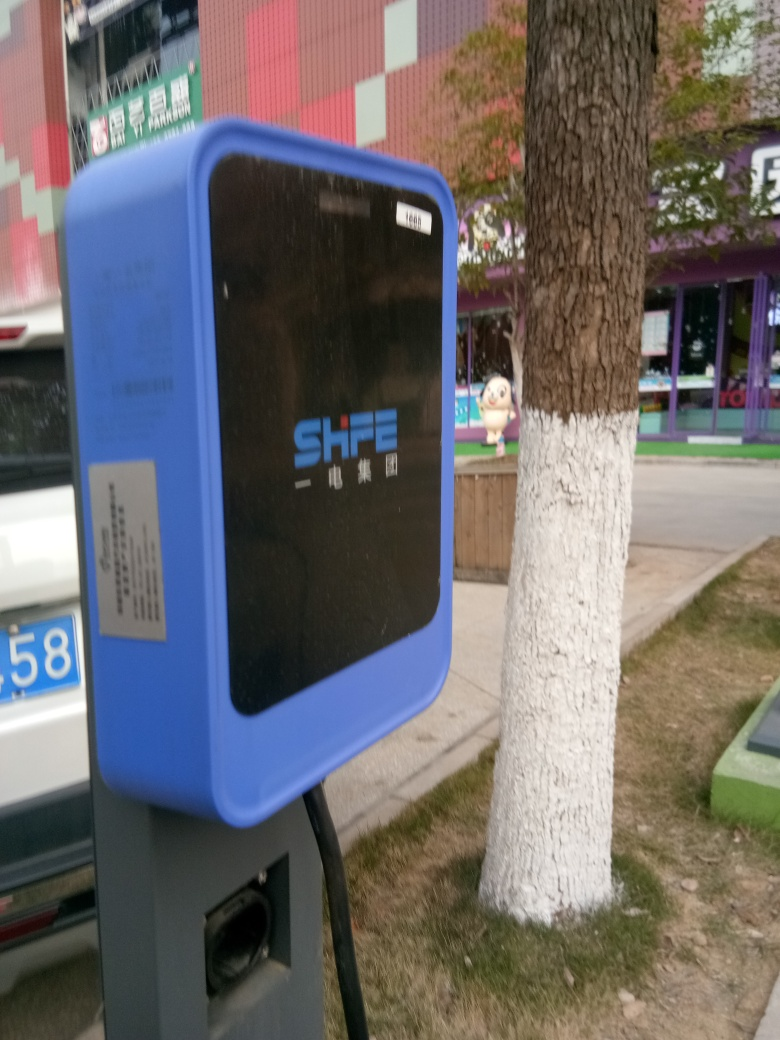Are the shops blurred?
 Yes 